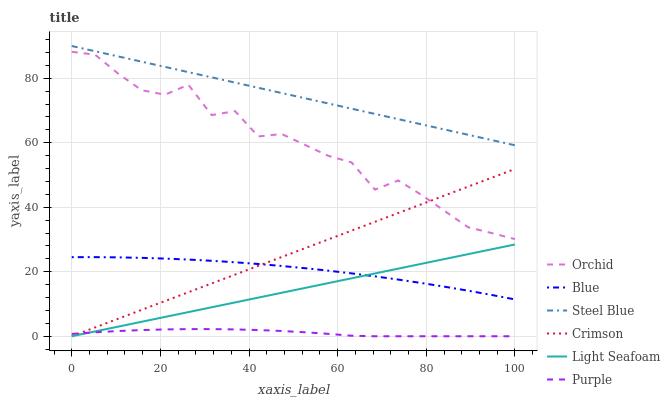Does Purple have the minimum area under the curve?
Answer yes or no. Yes. Does Steel Blue have the maximum area under the curve?
Answer yes or no. Yes. Does Steel Blue have the minimum area under the curve?
Answer yes or no. No. Does Purple have the maximum area under the curve?
Answer yes or no. No. Is Light Seafoam the smoothest?
Answer yes or no. Yes. Is Orchid the roughest?
Answer yes or no. Yes. Is Purple the smoothest?
Answer yes or no. No. Is Purple the roughest?
Answer yes or no. No. Does Purple have the lowest value?
Answer yes or no. Yes. Does Steel Blue have the lowest value?
Answer yes or no. No. Does Steel Blue have the highest value?
Answer yes or no. Yes. Does Purple have the highest value?
Answer yes or no. No. Is Purple less than Blue?
Answer yes or no. Yes. Is Steel Blue greater than Light Seafoam?
Answer yes or no. Yes. Does Blue intersect Light Seafoam?
Answer yes or no. Yes. Is Blue less than Light Seafoam?
Answer yes or no. No. Is Blue greater than Light Seafoam?
Answer yes or no. No. Does Purple intersect Blue?
Answer yes or no. No. 